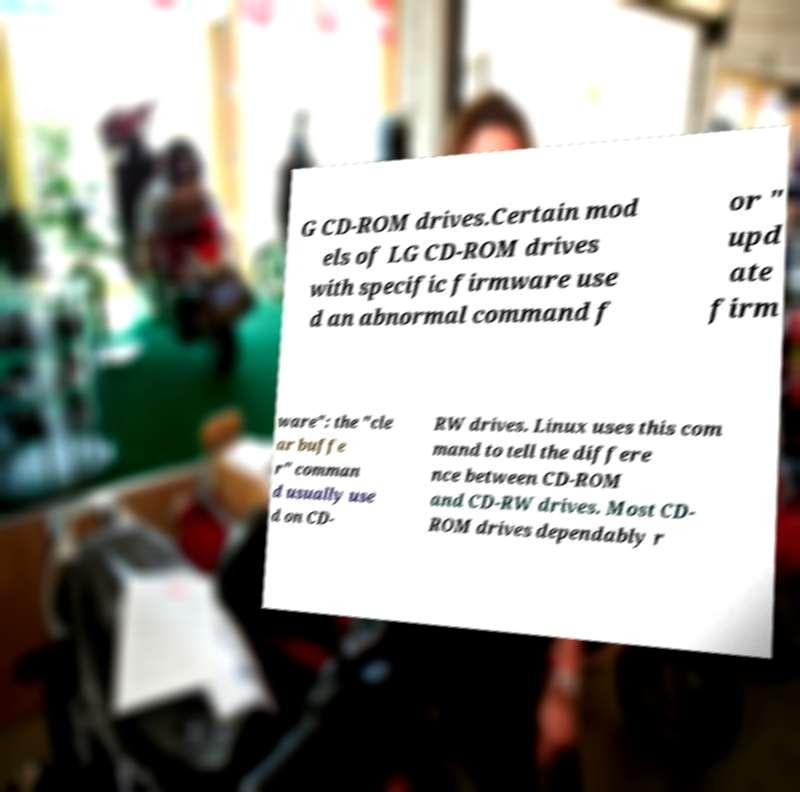Please read and relay the text visible in this image. What does it say? G CD-ROM drives.Certain mod els of LG CD-ROM drives with specific firmware use d an abnormal command f or " upd ate firm ware": the "cle ar buffe r" comman d usually use d on CD- RW drives. Linux uses this com mand to tell the differe nce between CD-ROM and CD-RW drives. Most CD- ROM drives dependably r 